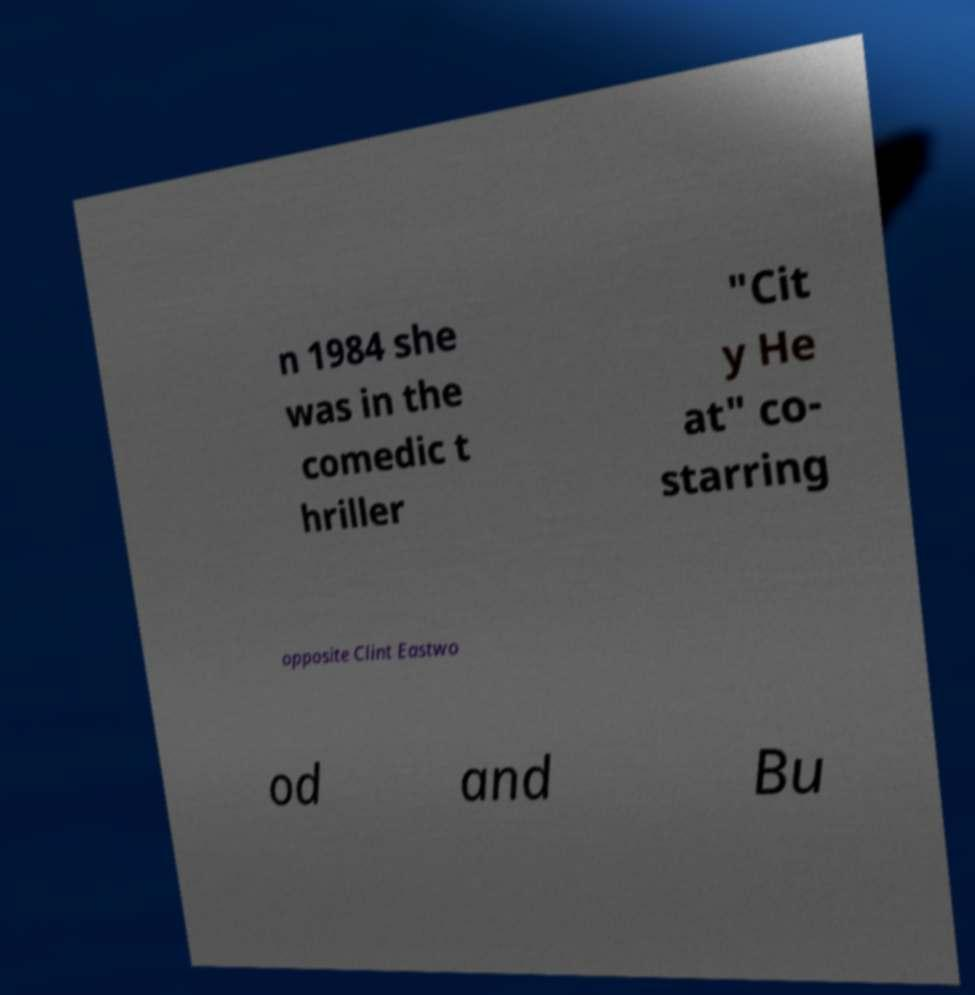Please identify and transcribe the text found in this image. n 1984 she was in the comedic t hriller "Cit y He at" co- starring opposite Clint Eastwo od and Bu 